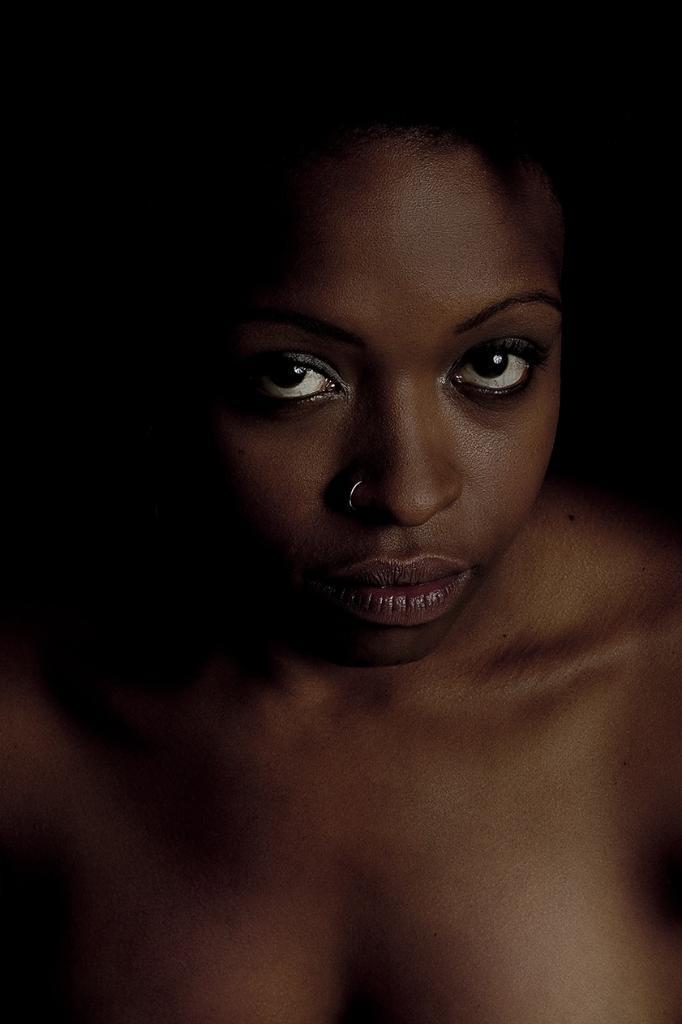Describe this image in one or two sentences. In this image we can see the face of a girl. 